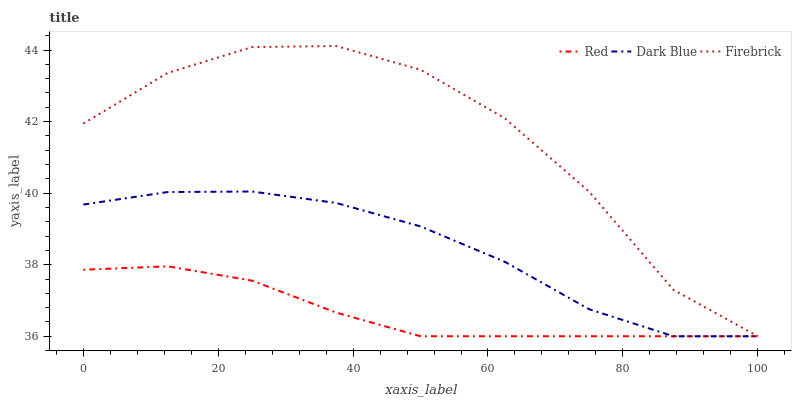Does Red have the minimum area under the curve?
Answer yes or no. Yes. Does Firebrick have the maximum area under the curve?
Answer yes or no. Yes. Does Firebrick have the minimum area under the curve?
Answer yes or no. No. Does Red have the maximum area under the curve?
Answer yes or no. No. Is Red the smoothest?
Answer yes or no. Yes. Is Firebrick the roughest?
Answer yes or no. Yes. Is Firebrick the smoothest?
Answer yes or no. No. Is Red the roughest?
Answer yes or no. No. Does Firebrick have the highest value?
Answer yes or no. Yes. Does Red have the highest value?
Answer yes or no. No. 